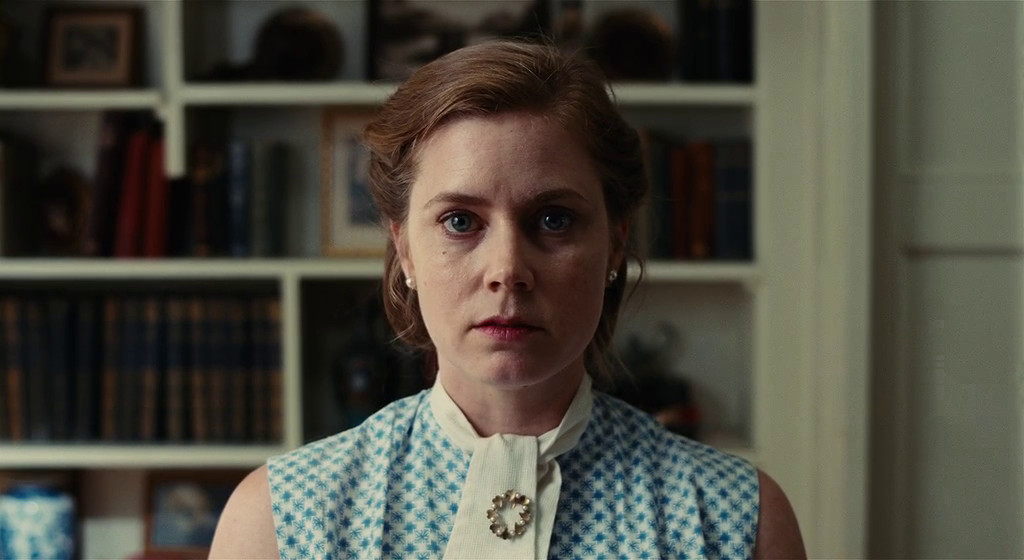How do the fashion choices of the character contribute to the portrayal of her personality or professional background? Her choice of a checkered dress with a classic white collar and a neatly positioned brooch portrays a blend of traditional and meticulous attention to detail. This fashion sense could imply that the character holds a position of authority or academia, where professionalism is key. The overall simplicity yet elegance of her outfit supports a persona that values both appearance and substance. 